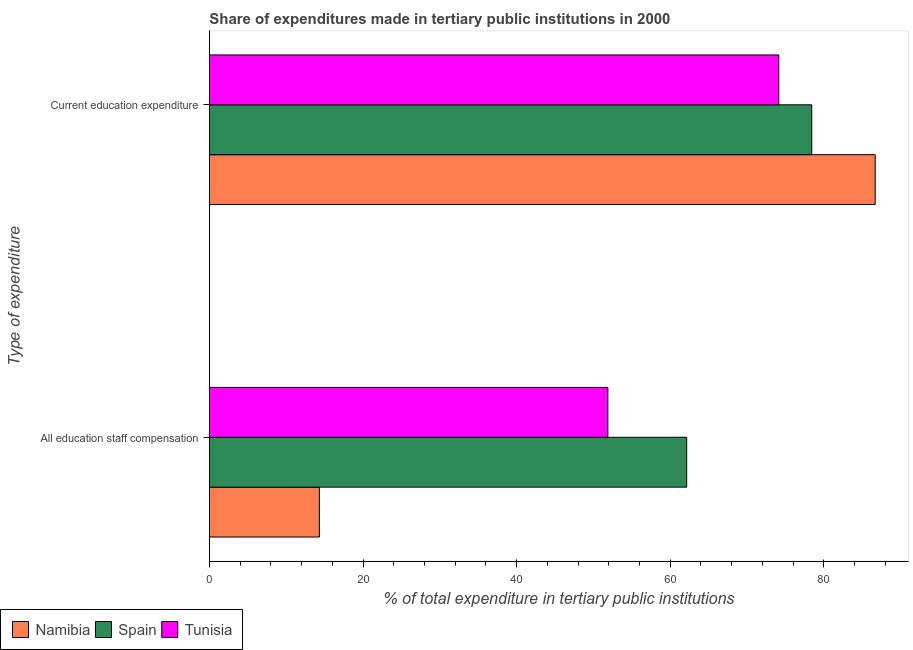How many different coloured bars are there?
Offer a very short reply. 3. How many groups of bars are there?
Offer a very short reply. 2. Are the number of bars per tick equal to the number of legend labels?
Ensure brevity in your answer.  Yes. Are the number of bars on each tick of the Y-axis equal?
Offer a very short reply. Yes. How many bars are there on the 2nd tick from the top?
Offer a terse response. 3. What is the label of the 2nd group of bars from the top?
Ensure brevity in your answer.  All education staff compensation. What is the expenditure in staff compensation in Namibia?
Your answer should be very brief. 14.32. Across all countries, what is the maximum expenditure in staff compensation?
Make the answer very short. 62.15. Across all countries, what is the minimum expenditure in staff compensation?
Your answer should be compact. 14.32. In which country was the expenditure in staff compensation maximum?
Offer a very short reply. Spain. In which country was the expenditure in staff compensation minimum?
Your answer should be compact. Namibia. What is the total expenditure in staff compensation in the graph?
Keep it short and to the point. 128.35. What is the difference between the expenditure in staff compensation in Tunisia and that in Namibia?
Your answer should be very brief. 37.57. What is the difference between the expenditure in education in Tunisia and the expenditure in staff compensation in Spain?
Your answer should be compact. 12. What is the average expenditure in education per country?
Provide a succinct answer. 79.76. What is the difference between the expenditure in staff compensation and expenditure in education in Namibia?
Your answer should be compact. -72.38. What is the ratio of the expenditure in education in Tunisia to that in Spain?
Keep it short and to the point. 0.95. Is the expenditure in education in Spain less than that in Namibia?
Offer a very short reply. Yes. What does the 3rd bar from the top in All education staff compensation represents?
Keep it short and to the point. Namibia. What does the 3rd bar from the bottom in Current education expenditure represents?
Offer a very short reply. Tunisia. How many countries are there in the graph?
Make the answer very short. 3. What is the difference between two consecutive major ticks on the X-axis?
Provide a succinct answer. 20. Are the values on the major ticks of X-axis written in scientific E-notation?
Provide a succinct answer. No. How are the legend labels stacked?
Provide a short and direct response. Horizontal. What is the title of the graph?
Make the answer very short. Share of expenditures made in tertiary public institutions in 2000. What is the label or title of the X-axis?
Offer a very short reply. % of total expenditure in tertiary public institutions. What is the label or title of the Y-axis?
Offer a terse response. Type of expenditure. What is the % of total expenditure in tertiary public institutions of Namibia in All education staff compensation?
Give a very brief answer. 14.32. What is the % of total expenditure in tertiary public institutions in Spain in All education staff compensation?
Your answer should be compact. 62.15. What is the % of total expenditure in tertiary public institutions in Tunisia in All education staff compensation?
Your response must be concise. 51.88. What is the % of total expenditure in tertiary public institutions in Namibia in Current education expenditure?
Keep it short and to the point. 86.7. What is the % of total expenditure in tertiary public institutions of Spain in Current education expenditure?
Your response must be concise. 78.44. What is the % of total expenditure in tertiary public institutions in Tunisia in Current education expenditure?
Give a very brief answer. 74.15. Across all Type of expenditure, what is the maximum % of total expenditure in tertiary public institutions in Namibia?
Give a very brief answer. 86.7. Across all Type of expenditure, what is the maximum % of total expenditure in tertiary public institutions in Spain?
Your answer should be compact. 78.44. Across all Type of expenditure, what is the maximum % of total expenditure in tertiary public institutions of Tunisia?
Ensure brevity in your answer.  74.15. Across all Type of expenditure, what is the minimum % of total expenditure in tertiary public institutions in Namibia?
Provide a succinct answer. 14.32. Across all Type of expenditure, what is the minimum % of total expenditure in tertiary public institutions of Spain?
Keep it short and to the point. 62.15. Across all Type of expenditure, what is the minimum % of total expenditure in tertiary public institutions of Tunisia?
Your answer should be very brief. 51.88. What is the total % of total expenditure in tertiary public institutions of Namibia in the graph?
Your answer should be compact. 101.02. What is the total % of total expenditure in tertiary public institutions in Spain in the graph?
Keep it short and to the point. 140.59. What is the total % of total expenditure in tertiary public institutions in Tunisia in the graph?
Your answer should be very brief. 126.03. What is the difference between the % of total expenditure in tertiary public institutions in Namibia in All education staff compensation and that in Current education expenditure?
Your answer should be compact. -72.38. What is the difference between the % of total expenditure in tertiary public institutions of Spain in All education staff compensation and that in Current education expenditure?
Ensure brevity in your answer.  -16.29. What is the difference between the % of total expenditure in tertiary public institutions in Tunisia in All education staff compensation and that in Current education expenditure?
Provide a short and direct response. -22.26. What is the difference between the % of total expenditure in tertiary public institutions in Namibia in All education staff compensation and the % of total expenditure in tertiary public institutions in Spain in Current education expenditure?
Offer a terse response. -64.12. What is the difference between the % of total expenditure in tertiary public institutions of Namibia in All education staff compensation and the % of total expenditure in tertiary public institutions of Tunisia in Current education expenditure?
Provide a succinct answer. -59.83. What is the difference between the % of total expenditure in tertiary public institutions of Spain in All education staff compensation and the % of total expenditure in tertiary public institutions of Tunisia in Current education expenditure?
Give a very brief answer. -12. What is the average % of total expenditure in tertiary public institutions in Namibia per Type of expenditure?
Your answer should be very brief. 50.51. What is the average % of total expenditure in tertiary public institutions in Spain per Type of expenditure?
Give a very brief answer. 70.29. What is the average % of total expenditure in tertiary public institutions of Tunisia per Type of expenditure?
Your answer should be compact. 63.02. What is the difference between the % of total expenditure in tertiary public institutions of Namibia and % of total expenditure in tertiary public institutions of Spain in All education staff compensation?
Give a very brief answer. -47.83. What is the difference between the % of total expenditure in tertiary public institutions in Namibia and % of total expenditure in tertiary public institutions in Tunisia in All education staff compensation?
Keep it short and to the point. -37.57. What is the difference between the % of total expenditure in tertiary public institutions in Spain and % of total expenditure in tertiary public institutions in Tunisia in All education staff compensation?
Provide a short and direct response. 10.27. What is the difference between the % of total expenditure in tertiary public institutions of Namibia and % of total expenditure in tertiary public institutions of Spain in Current education expenditure?
Your answer should be very brief. 8.26. What is the difference between the % of total expenditure in tertiary public institutions of Namibia and % of total expenditure in tertiary public institutions of Tunisia in Current education expenditure?
Make the answer very short. 12.55. What is the difference between the % of total expenditure in tertiary public institutions in Spain and % of total expenditure in tertiary public institutions in Tunisia in Current education expenditure?
Your response must be concise. 4.29. What is the ratio of the % of total expenditure in tertiary public institutions of Namibia in All education staff compensation to that in Current education expenditure?
Ensure brevity in your answer.  0.17. What is the ratio of the % of total expenditure in tertiary public institutions of Spain in All education staff compensation to that in Current education expenditure?
Provide a succinct answer. 0.79. What is the ratio of the % of total expenditure in tertiary public institutions of Tunisia in All education staff compensation to that in Current education expenditure?
Keep it short and to the point. 0.7. What is the difference between the highest and the second highest % of total expenditure in tertiary public institutions of Namibia?
Give a very brief answer. 72.38. What is the difference between the highest and the second highest % of total expenditure in tertiary public institutions of Spain?
Offer a terse response. 16.29. What is the difference between the highest and the second highest % of total expenditure in tertiary public institutions in Tunisia?
Keep it short and to the point. 22.26. What is the difference between the highest and the lowest % of total expenditure in tertiary public institutions in Namibia?
Provide a short and direct response. 72.38. What is the difference between the highest and the lowest % of total expenditure in tertiary public institutions of Spain?
Give a very brief answer. 16.29. What is the difference between the highest and the lowest % of total expenditure in tertiary public institutions of Tunisia?
Provide a short and direct response. 22.26. 